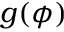<formula> <loc_0><loc_0><loc_500><loc_500>g ( \phi )</formula> 